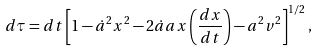Convert formula to latex. <formula><loc_0><loc_0><loc_500><loc_500>d \tau = d t \left [ 1 - \dot { a } ^ { 2 } x ^ { 2 } - 2 \dot { a } a x \left ( \frac { d x } { d t } \right ) - a ^ { 2 } v ^ { 2 } \right ] ^ { 1 / 2 } ,</formula> 